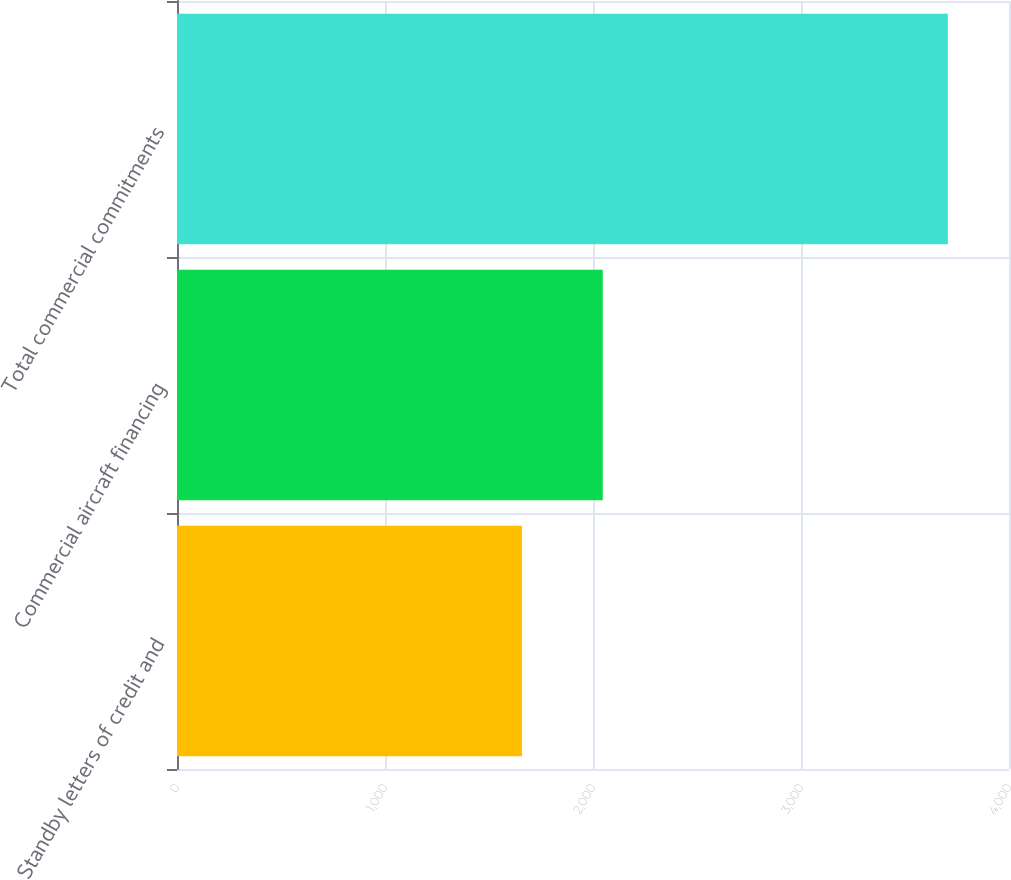Convert chart to OTSL. <chart><loc_0><loc_0><loc_500><loc_500><bar_chart><fcel>Standby letters of credit and<fcel>Commercial aircraft financing<fcel>Total commercial commitments<nl><fcel>1659<fcel>2047<fcel>3706<nl></chart> 